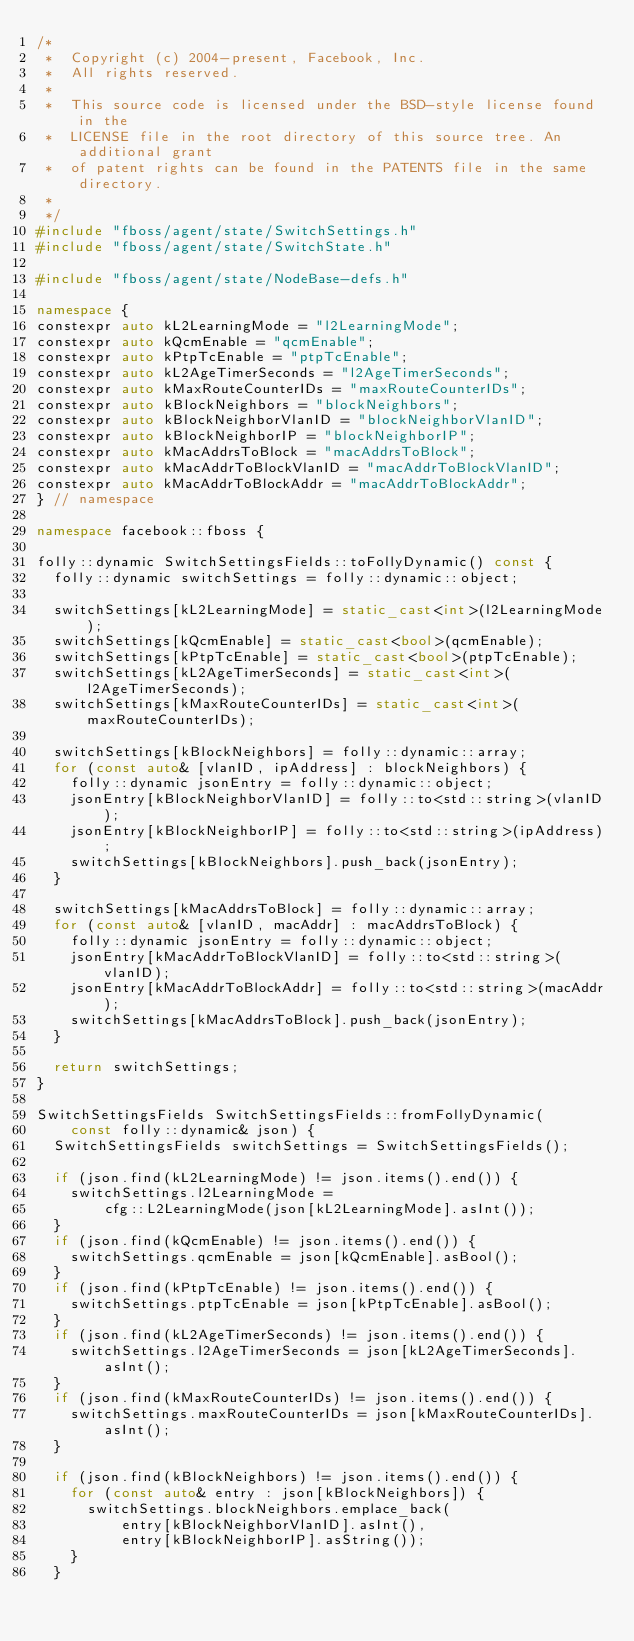Convert code to text. <code><loc_0><loc_0><loc_500><loc_500><_C++_>/*
 *  Copyright (c) 2004-present, Facebook, Inc.
 *  All rights reserved.
 *
 *  This source code is licensed under the BSD-style license found in the
 *  LICENSE file in the root directory of this source tree. An additional grant
 *  of patent rights can be found in the PATENTS file in the same directory.
 *
 */
#include "fboss/agent/state/SwitchSettings.h"
#include "fboss/agent/state/SwitchState.h"

#include "fboss/agent/state/NodeBase-defs.h"

namespace {
constexpr auto kL2LearningMode = "l2LearningMode";
constexpr auto kQcmEnable = "qcmEnable";
constexpr auto kPtpTcEnable = "ptpTcEnable";
constexpr auto kL2AgeTimerSeconds = "l2AgeTimerSeconds";
constexpr auto kMaxRouteCounterIDs = "maxRouteCounterIDs";
constexpr auto kBlockNeighbors = "blockNeighbors";
constexpr auto kBlockNeighborVlanID = "blockNeighborVlanID";
constexpr auto kBlockNeighborIP = "blockNeighborIP";
constexpr auto kMacAddrsToBlock = "macAddrsToBlock";
constexpr auto kMacAddrToBlockVlanID = "macAddrToBlockVlanID";
constexpr auto kMacAddrToBlockAddr = "macAddrToBlockAddr";
} // namespace

namespace facebook::fboss {

folly::dynamic SwitchSettingsFields::toFollyDynamic() const {
  folly::dynamic switchSettings = folly::dynamic::object;

  switchSettings[kL2LearningMode] = static_cast<int>(l2LearningMode);
  switchSettings[kQcmEnable] = static_cast<bool>(qcmEnable);
  switchSettings[kPtpTcEnable] = static_cast<bool>(ptpTcEnable);
  switchSettings[kL2AgeTimerSeconds] = static_cast<int>(l2AgeTimerSeconds);
  switchSettings[kMaxRouteCounterIDs] = static_cast<int>(maxRouteCounterIDs);

  switchSettings[kBlockNeighbors] = folly::dynamic::array;
  for (const auto& [vlanID, ipAddress] : blockNeighbors) {
    folly::dynamic jsonEntry = folly::dynamic::object;
    jsonEntry[kBlockNeighborVlanID] = folly::to<std::string>(vlanID);
    jsonEntry[kBlockNeighborIP] = folly::to<std::string>(ipAddress);
    switchSettings[kBlockNeighbors].push_back(jsonEntry);
  }

  switchSettings[kMacAddrsToBlock] = folly::dynamic::array;
  for (const auto& [vlanID, macAddr] : macAddrsToBlock) {
    folly::dynamic jsonEntry = folly::dynamic::object;
    jsonEntry[kMacAddrToBlockVlanID] = folly::to<std::string>(vlanID);
    jsonEntry[kMacAddrToBlockAddr] = folly::to<std::string>(macAddr);
    switchSettings[kMacAddrsToBlock].push_back(jsonEntry);
  }

  return switchSettings;
}

SwitchSettingsFields SwitchSettingsFields::fromFollyDynamic(
    const folly::dynamic& json) {
  SwitchSettingsFields switchSettings = SwitchSettingsFields();

  if (json.find(kL2LearningMode) != json.items().end()) {
    switchSettings.l2LearningMode =
        cfg::L2LearningMode(json[kL2LearningMode].asInt());
  }
  if (json.find(kQcmEnable) != json.items().end()) {
    switchSettings.qcmEnable = json[kQcmEnable].asBool();
  }
  if (json.find(kPtpTcEnable) != json.items().end()) {
    switchSettings.ptpTcEnable = json[kPtpTcEnable].asBool();
  }
  if (json.find(kL2AgeTimerSeconds) != json.items().end()) {
    switchSettings.l2AgeTimerSeconds = json[kL2AgeTimerSeconds].asInt();
  }
  if (json.find(kMaxRouteCounterIDs) != json.items().end()) {
    switchSettings.maxRouteCounterIDs = json[kMaxRouteCounterIDs].asInt();
  }

  if (json.find(kBlockNeighbors) != json.items().end()) {
    for (const auto& entry : json[kBlockNeighbors]) {
      switchSettings.blockNeighbors.emplace_back(
          entry[kBlockNeighborVlanID].asInt(),
          entry[kBlockNeighborIP].asString());
    }
  }
</code> 